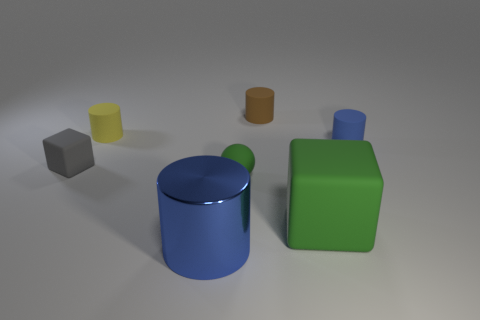Can you describe the differences in size and color among the objects shown? Certainly! In the image, there are five distinct objects, each varying in size and color. Starting from the left, there's a smaller gray cube, a medium-sized yellow cylinder, a large blue cylinder, a small orange cylinder, and finally, a green rectangular prism which appears to be the largest. The blue and yellow objects have a vibrant, glossy finish, suggesting a smooth surface, while the gray, orange, and green objects show a more matte finish. 